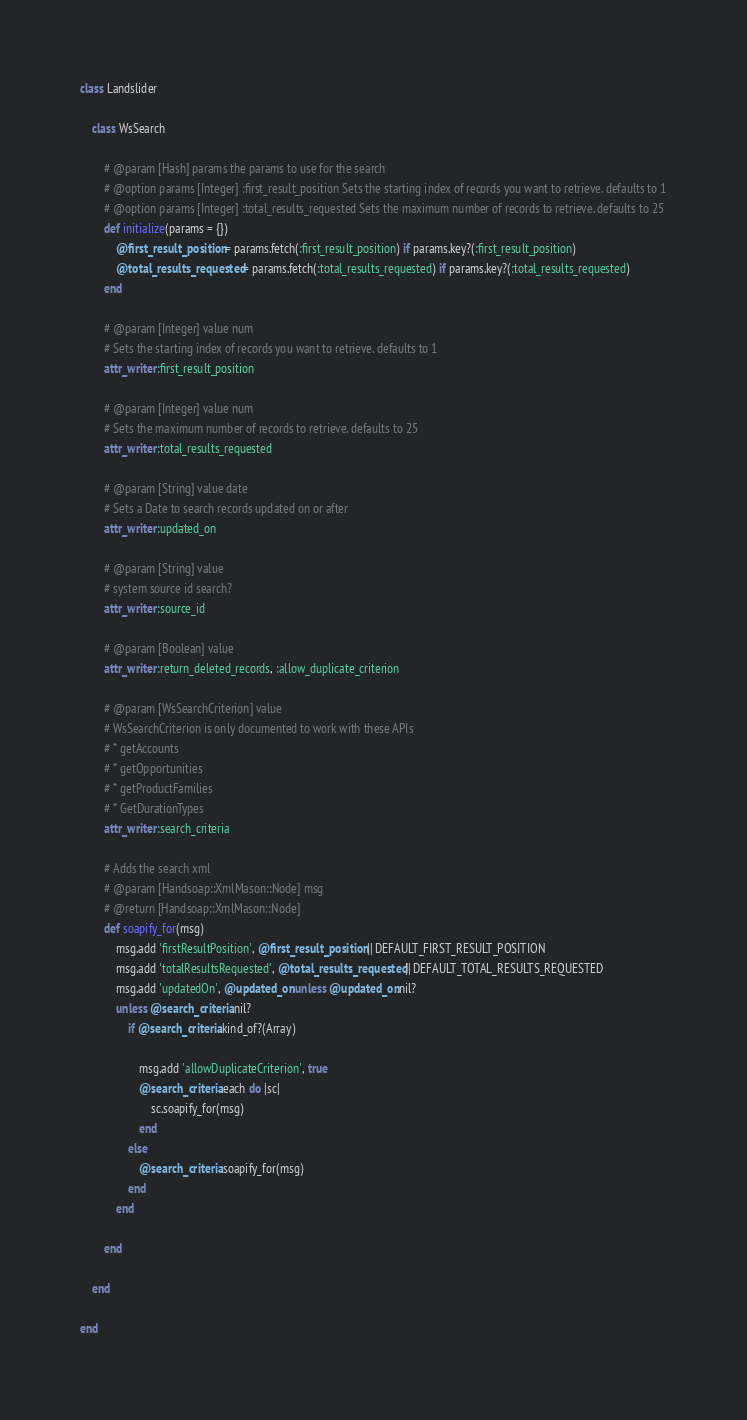Convert code to text. <code><loc_0><loc_0><loc_500><loc_500><_Ruby_>
class Landslider

	class WsSearch

		# @param [Hash] params the params to use for the search
		# @option params [Integer] :first_result_position Sets the starting index of records you want to retrieve. defaults to 1
		# @option params [Integer] :total_results_requested Sets the maximum number of records to retrieve. defaults to 25
		def initialize(params = {})
		    @first_result_position = params.fetch(:first_result_position) if params.key?(:first_result_position)
		    @total_results_requested = params.fetch(:total_results_requested) if params.key?(:total_results_requested)
		end
		
		# @param [Integer] value num
		# Sets the starting index of records you want to retrieve. defaults to 1
		attr_writer :first_result_position
		
		# @param [Integer] value num
		# Sets the maximum number of records to retrieve. defaults to 25
		attr_writer :total_results_requested
		
		# @param [String] value date
		# Sets a Date to search records updated on or after
		attr_writer :updated_on
		
		# @param [String] value
		# system source id search?
		attr_writer :source_id
		
		# @param [Boolean] value
		attr_writer :return_deleted_records, :allow_duplicate_criterion
		
		# @param [WsSearchCriterion] value 
		# WsSearchCriterion is only documented to work with these APIs
		# * getAccounts
		# * getOpportunities
		# * getProductFamilies
		# * GetDurationTypes
		attr_writer :search_criteria
	
		# Adds the search xml
		# @param [Handsoap::XmlMason::Node] msg
		# @return [Handsoap::XmlMason::Node]
		def soapify_for(msg)
			msg.add 'firstResultPosition', @first_result_position || DEFAULT_FIRST_RESULT_POSITION
			msg.add 'totalResultsRequested', @total_results_requested || DEFAULT_TOTAL_RESULTS_REQUESTED
			msg.add 'updatedOn', @updated_on unless @updated_on.nil?
			unless @search_criteria.nil?
				if @search_criteria.kind_of?(Array)

					msg.add 'allowDuplicateCriterion', true
					@search_criteria.each do |sc|
						sc.soapify_for(msg)
					end
				else
					@search_criteria.soapify_for(msg)
				end
			end
		
		end

	end

end
</code> 